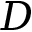<formula> <loc_0><loc_0><loc_500><loc_500>D</formula> 